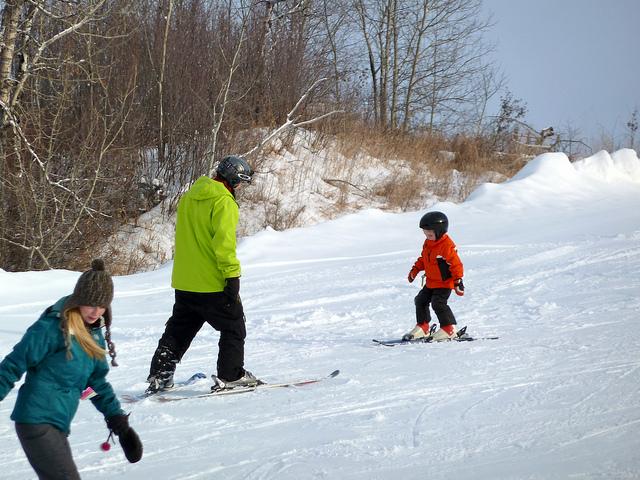How many people in this photo have long hair?
Concise answer only. 1. Are the trees leafless?
Quick response, please. Yes. How many people are wearing helmets in this picture?
Keep it brief. 2. 